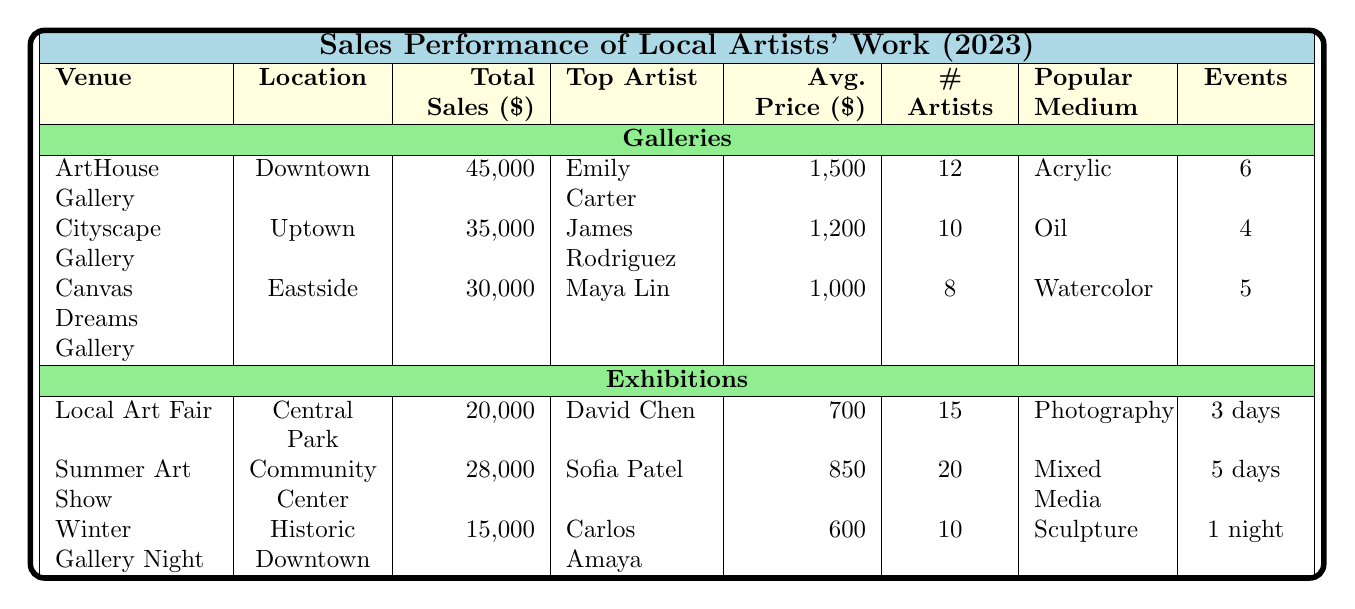What is the total sales amount for ArtHouse Gallery? The table shows the total sales amount for ArtHouse Gallery, which is listed under the "Total Sales" column. The value is $45,000.
Answer: 45000 Who is the top artist at Canvas Dreams Gallery? The table indicates the top artist for Canvas Dreams Gallery under the "Top Artist" column, which is Maya Lin.
Answer: Maya Lin Which gallery generated the highest average price for artworks sold? By comparing the average prices in the "Avg. Price" column, ArtHouse Gallery has the highest average price at $1,500 compared to Cityscape Gallery ($1,200) and Canvas Dreams Gallery ($1,000).
Answer: ArtHouse Gallery How many artists participated in the Summer Art Show? The "Number of Artists" column for the Summer Art Show states that there were 20 artists who participated.
Answer: 20 What is the total sales for all exhibitions combined? To find the total sales for exhibitions, we need to sum the total sales of all individual exhibitions: 20,000 (Local Art Fair) + 28,000 (Summer Art Show) + 15,000 (Winter Gallery Night) = 63,000.
Answer: 63000 Is the most popular medium for Cityscape Gallery Oil? The table lists the most popular medium under the "Popular Medium" column for Cityscape Gallery, which is Oil, confirming the statement is true.
Answer: Yes Which event has the shortest duration? Comparing the "Duration" column, Winter Gallery Night has the shortest duration listed as "1 night," shorter than the other events.
Answer: 1 night What are the total sales figures for galleries versus exhibitions? For galleries: 45,000 (ArtHouse) + 35,000 (Cityscape) + 30,000 (Canvas Dreams) = 110,000. For exhibitions: 20,000 (Local Art Fair) + 28,000 (Summer Art Show) + 15,000 (Winter Gallery Night) = 63,000. Galleries sold more than exhibitions.
Answer: Galleries: 110000, Exhibitions: 63000 Which gallery had the most exhibition events? According to the "Events" column, ArtHouse Gallery hosted 6 events, which is the highest compared to Cityscape Gallery (4) and Canvas Dreams Gallery (5).
Answer: ArtHouse Gallery What is the average price of art sold at the Local Art Fair? The "Avg. Price" column shows that the average price at the Local Art Fair is $700.
Answer: 700 